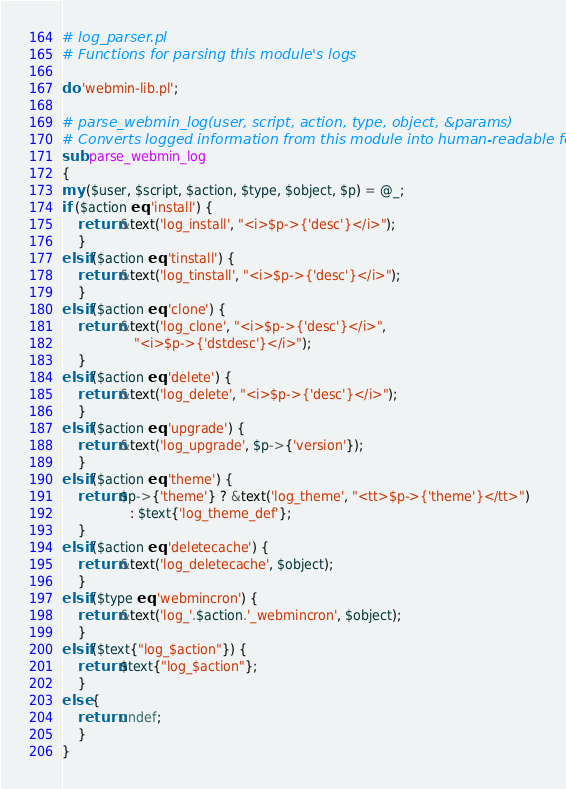Convert code to text. <code><loc_0><loc_0><loc_500><loc_500><_Perl_># log_parser.pl
# Functions for parsing this module's logs

do 'webmin-lib.pl';

# parse_webmin_log(user, script, action, type, object, &params)
# Converts logged information from this module into human-readable form
sub parse_webmin_log
{
my ($user, $script, $action, $type, $object, $p) = @_;
if ($action eq 'install') {
	return &text('log_install', "<i>$p->{'desc'}</i>");
	}
elsif ($action eq 'tinstall') {
	return &text('log_tinstall', "<i>$p->{'desc'}</i>");
	}
elsif ($action eq 'clone') {
	return &text('log_clone', "<i>$p->{'desc'}</i>",
				  "<i>$p->{'dstdesc'}</i>");
	}
elsif ($action eq 'delete') {
	return &text('log_delete', "<i>$p->{'desc'}</i>");
	}
elsif ($action eq 'upgrade') {
	return &text('log_upgrade', $p->{'version'});
	}
elsif ($action eq 'theme') {
	return $p->{'theme'} ? &text('log_theme', "<tt>$p->{'theme'}</tt>")
			     : $text{'log_theme_def'};
	}
elsif ($action eq 'deletecache') {
	return &text('log_deletecache', $object);
	}
elsif ($type eq 'webmincron') {
	return &text('log_'.$action.'_webmincron', $object);
	}
elsif ($text{"log_$action"}) {
	return $text{"log_$action"};
	}
else {
	return undef;
	}
}

</code> 